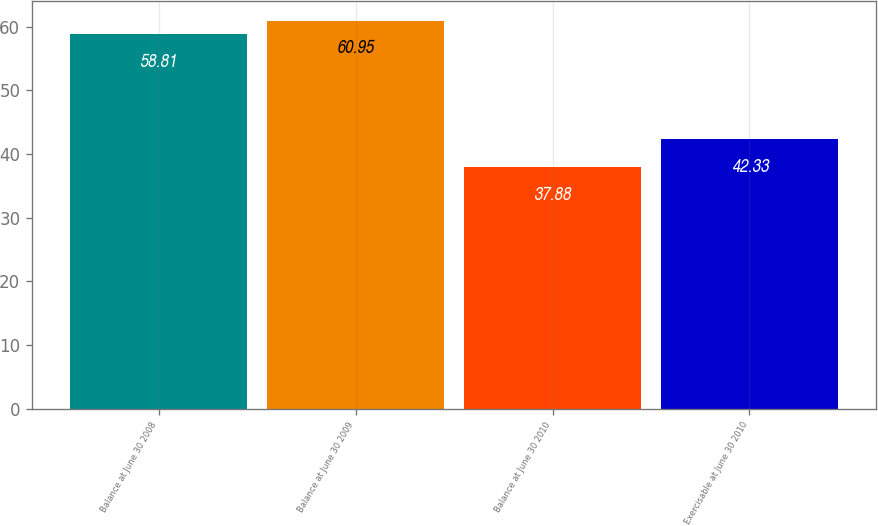Convert chart. <chart><loc_0><loc_0><loc_500><loc_500><bar_chart><fcel>Balance at June 30 2008<fcel>Balance at June 30 2009<fcel>Balance at June 30 2010<fcel>Exercisable at June 30 2010<nl><fcel>58.81<fcel>60.95<fcel>37.88<fcel>42.33<nl></chart> 